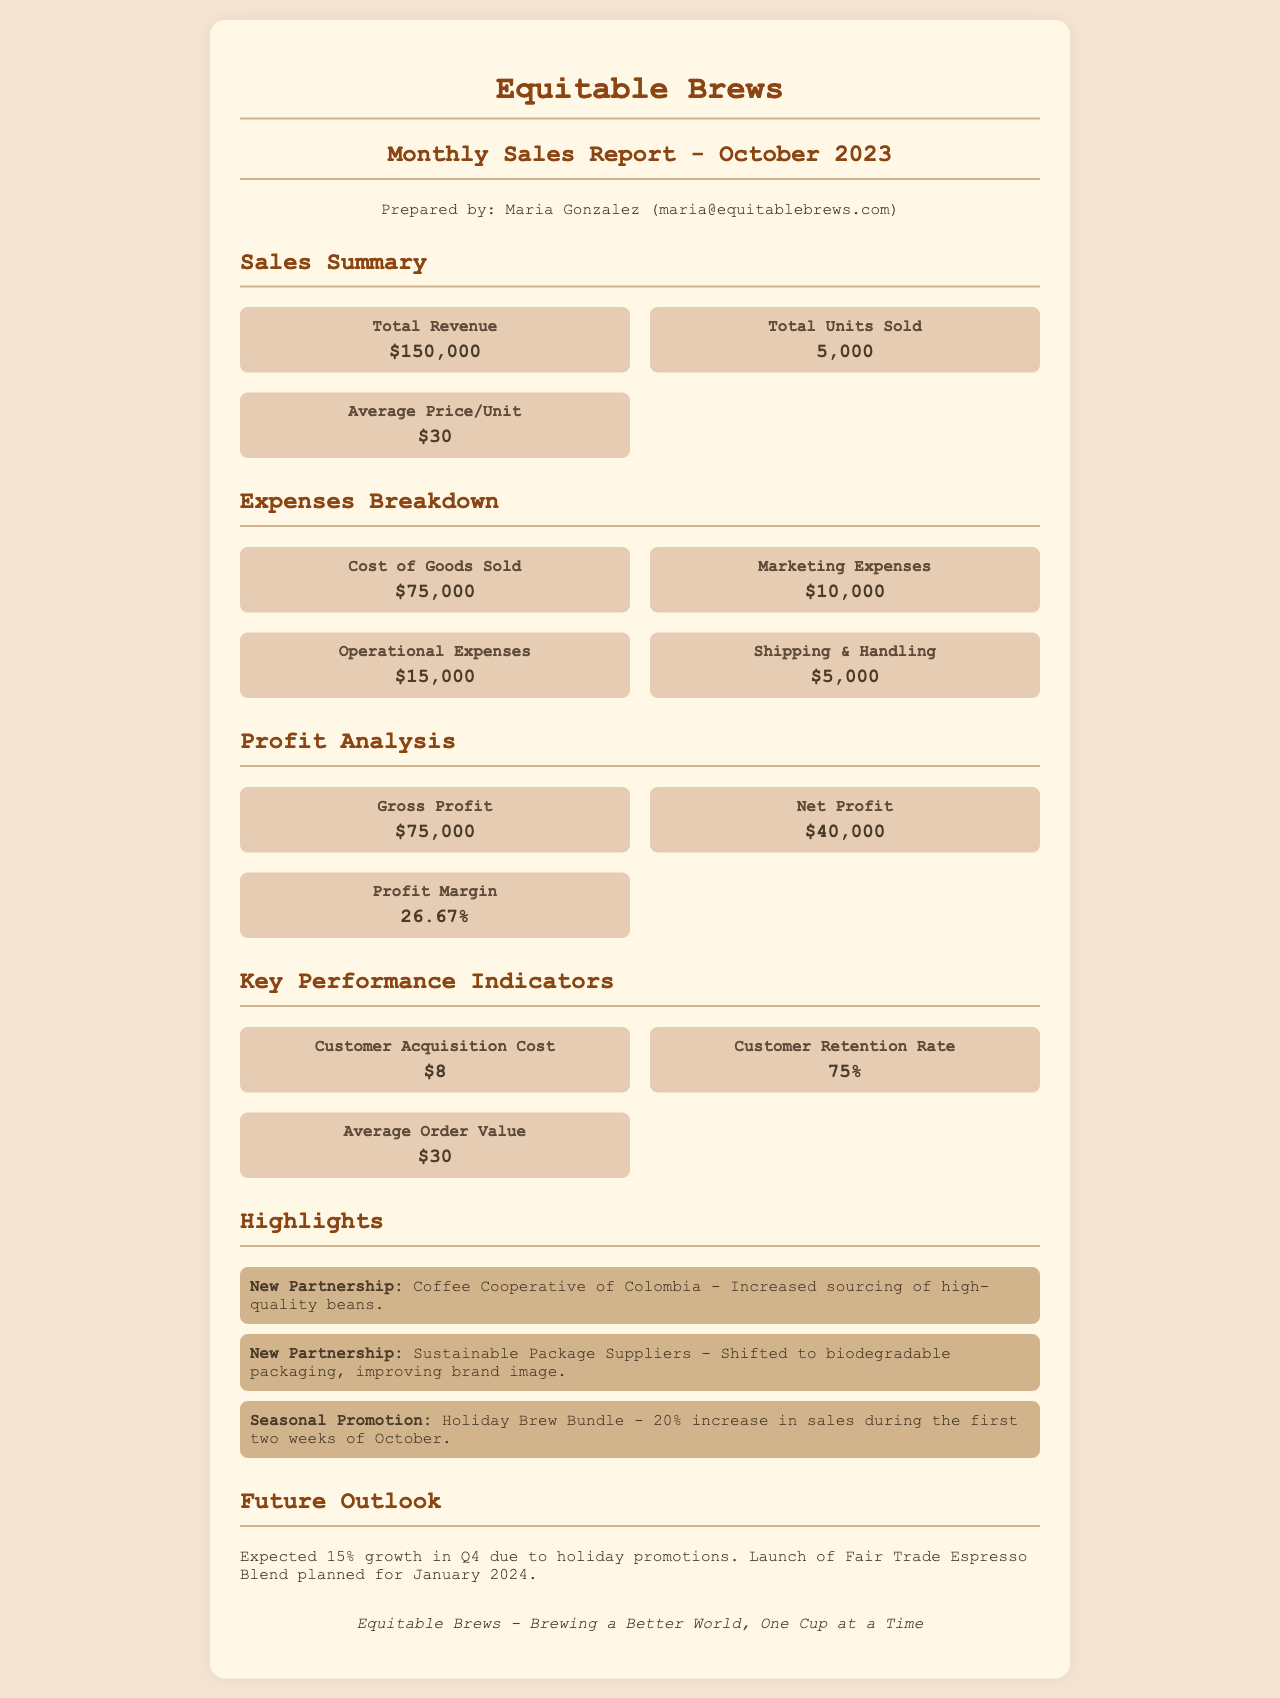what is the total revenue? The total revenue is listed in the Sales Summary section of the document as $150,000.
Answer: $150,000 how many units were sold? The total units sold is provided in the Sales Summary section of the document, showing a total of 5,000 units.
Answer: 5,000 what are the marketing expenses? The marketing expenses can be found in the Expenses Breakdown section, where it states the amount as $10,000.
Answer: $10,000 what is the profit margin? The profit margin is calculated in the Profit Analysis section, which shows it as 26.67%.
Answer: 26.67% what is the customer acquisition cost? The customer acquisition cost is noted in the Key Performance Indicators section as $8.
Answer: $8 what is the gross profit? The gross profit is detailed in the Profit Analysis section as $75,000.
Answer: $75,000 what is the expected growth for Q4? The document states that there is an expected growth of 15% in Q4 due to holiday promotions.
Answer: 15% name one new partnership. The highlights section mentions a new partnership with the Coffee Cooperative of Colombia for sourcing high-quality beans.
Answer: Coffee Cooperative of Colombia what was the impact of the seasonal promotion? The seasonal promotion, Holiday Brew Bundle, resulted in a 20% increase in sales during the first two weeks of October.
Answer: 20% increase 